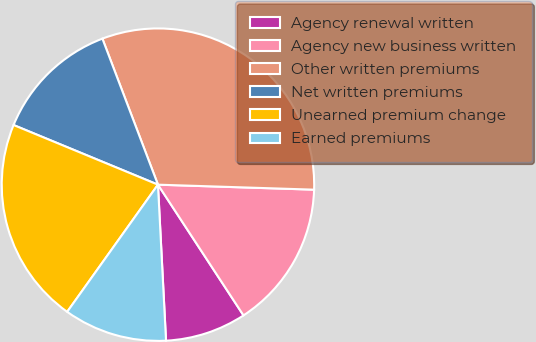Convert chart. <chart><loc_0><loc_0><loc_500><loc_500><pie_chart><fcel>Agency renewal written<fcel>Agency new business written<fcel>Other written premiums<fcel>Net written premiums<fcel>Unearned premium change<fcel>Earned premiums<nl><fcel>8.4%<fcel>15.27%<fcel>31.3%<fcel>12.98%<fcel>21.37%<fcel>10.69%<nl></chart> 